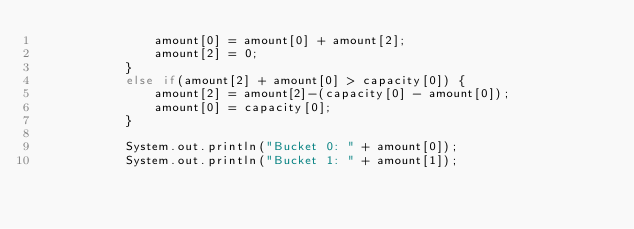<code> <loc_0><loc_0><loc_500><loc_500><_Java_>				amount[0] = amount[0] + amount[2];
				amount[2] = 0;
			}
			else if(amount[2] + amount[0] > capacity[0]) {
				amount[2] = amount[2]-(capacity[0] - amount[0]);
				amount[0] = capacity[0];
			}
			
			System.out.println("Bucket 0: " + amount[0]);
			System.out.println("Bucket 1: " + amount[1]);</code> 